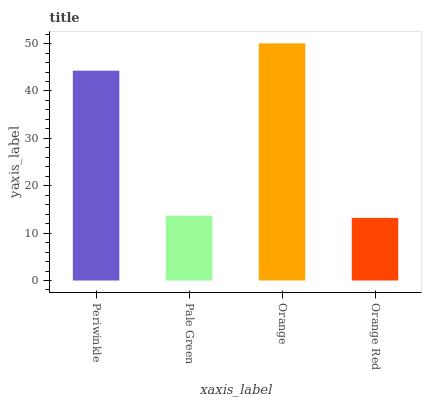Is Orange Red the minimum?
Answer yes or no. Yes. Is Orange the maximum?
Answer yes or no. Yes. Is Pale Green the minimum?
Answer yes or no. No. Is Pale Green the maximum?
Answer yes or no. No. Is Periwinkle greater than Pale Green?
Answer yes or no. Yes. Is Pale Green less than Periwinkle?
Answer yes or no. Yes. Is Pale Green greater than Periwinkle?
Answer yes or no. No. Is Periwinkle less than Pale Green?
Answer yes or no. No. Is Periwinkle the high median?
Answer yes or no. Yes. Is Pale Green the low median?
Answer yes or no. Yes. Is Orange the high median?
Answer yes or no. No. Is Orange the low median?
Answer yes or no. No. 